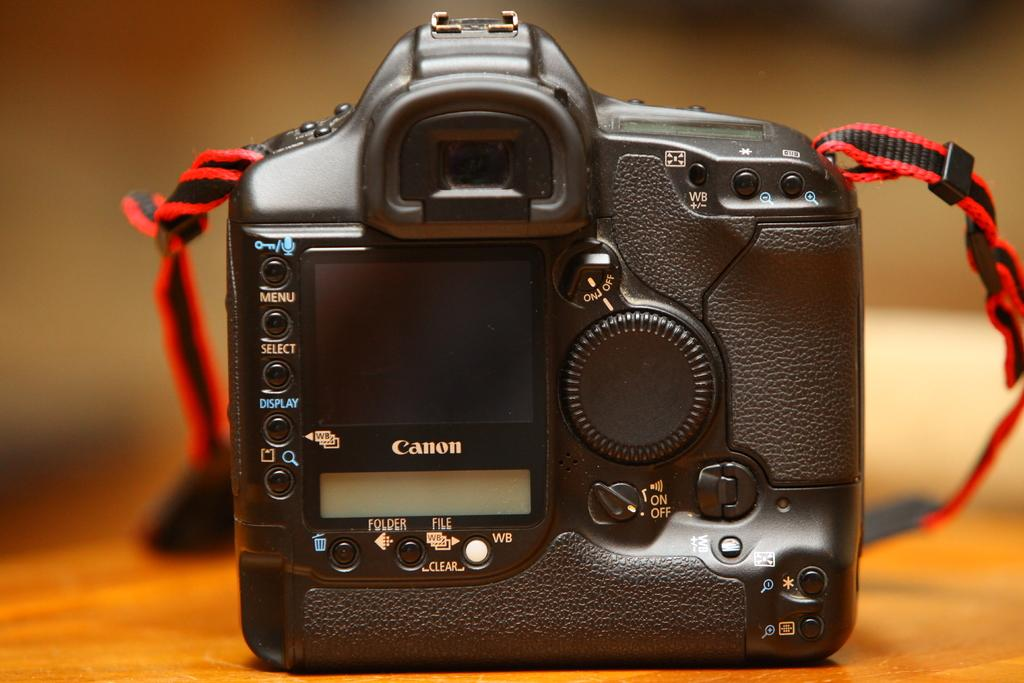What is the main object in the image? There is a camera in the image. Where is the camera positioned? The camera is on a platform. What can be observed about the background of the image? The background of the image is blurred. What type of attack is being carried out by the geese in the image? There are no geese present in the image, so no attack can be observed. 